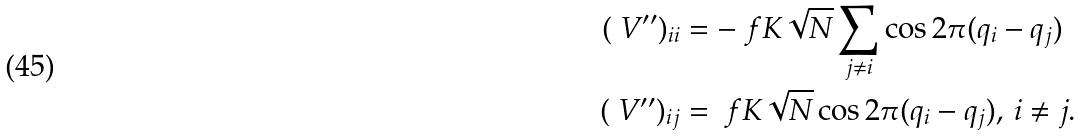Convert formula to latex. <formula><loc_0><loc_0><loc_500><loc_500>( \ V ^ { \prime \prime } ) _ { i i } & = - \ f { K } { \sqrt { N } } \sum _ { j \ne i } \cos 2 \pi ( q _ { i } - q _ { j } ) \\ ( \ V ^ { \prime \prime } ) _ { i j } & = \ f { K } { \sqrt { N } } \cos 2 \pi ( q _ { i } - q _ { j } ) , \, i \ne j .</formula> 